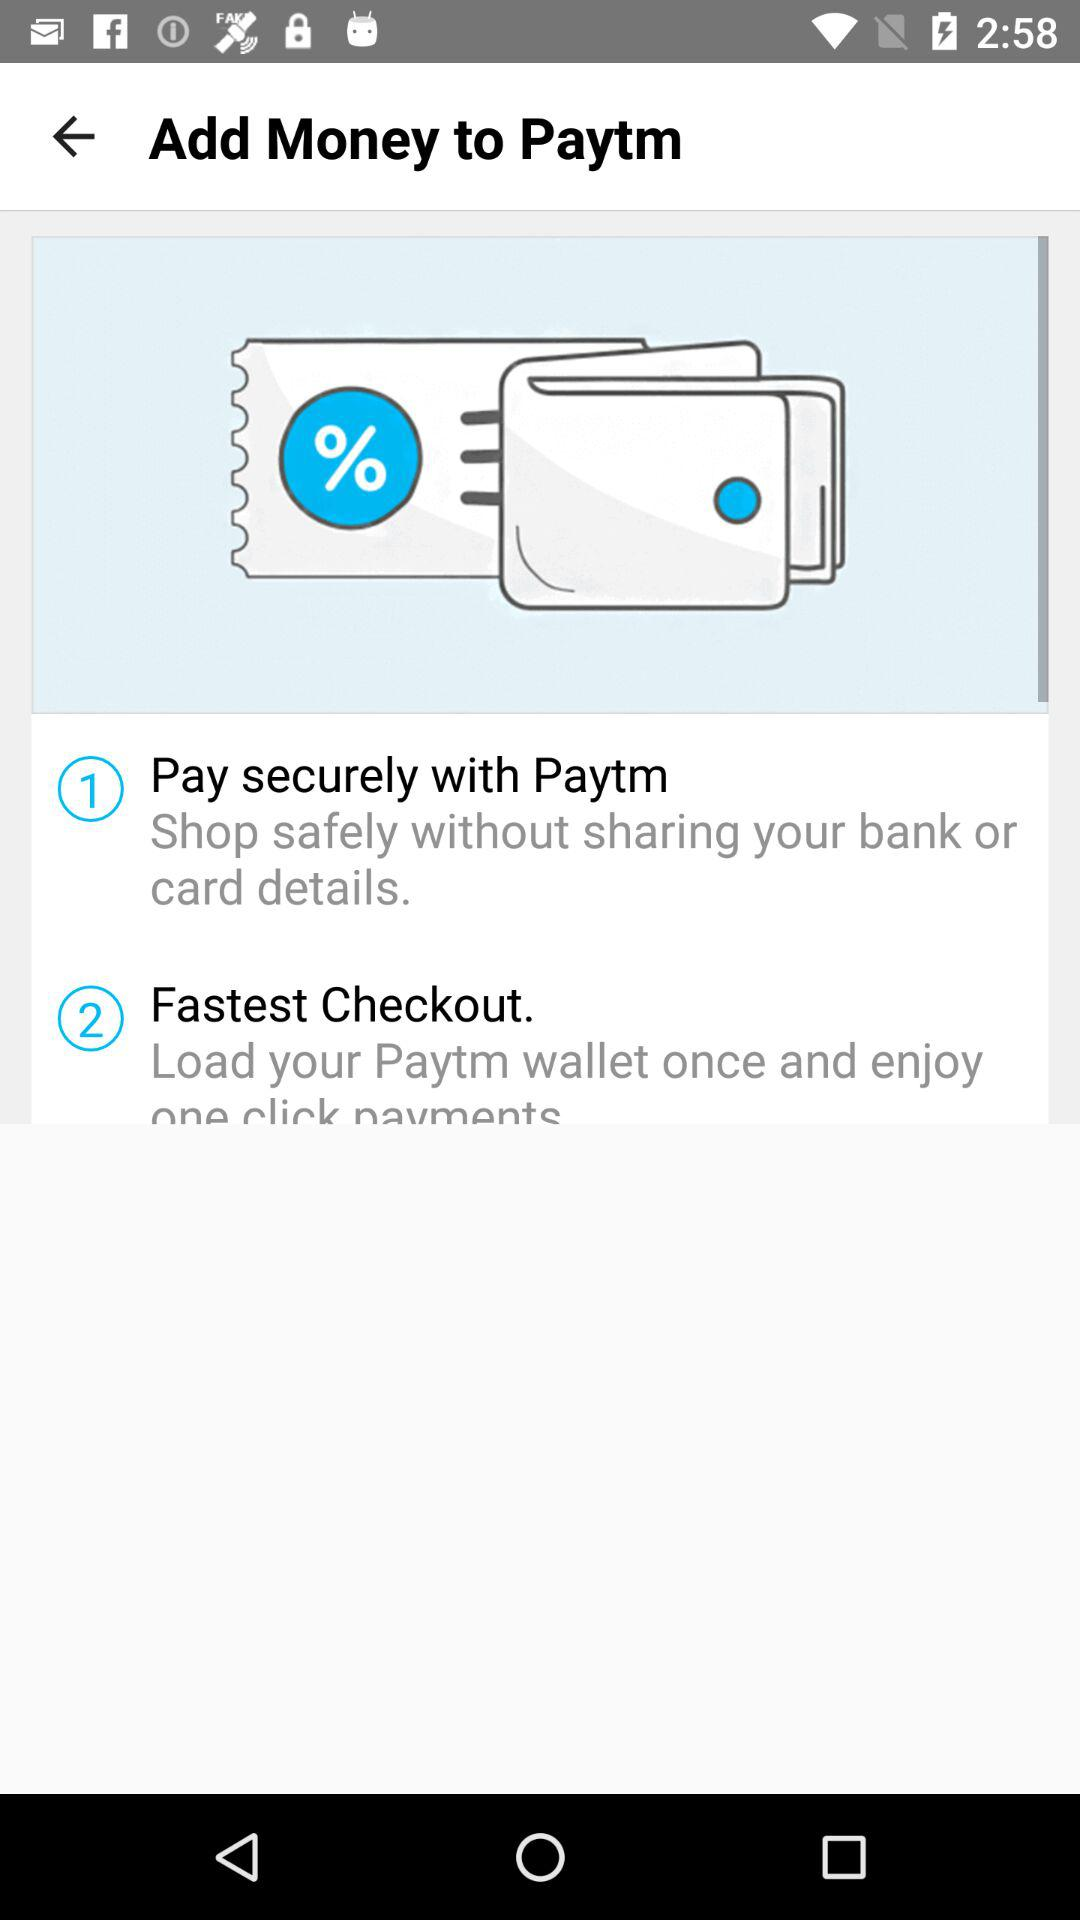What is the app name? The app name is "Paytm". 